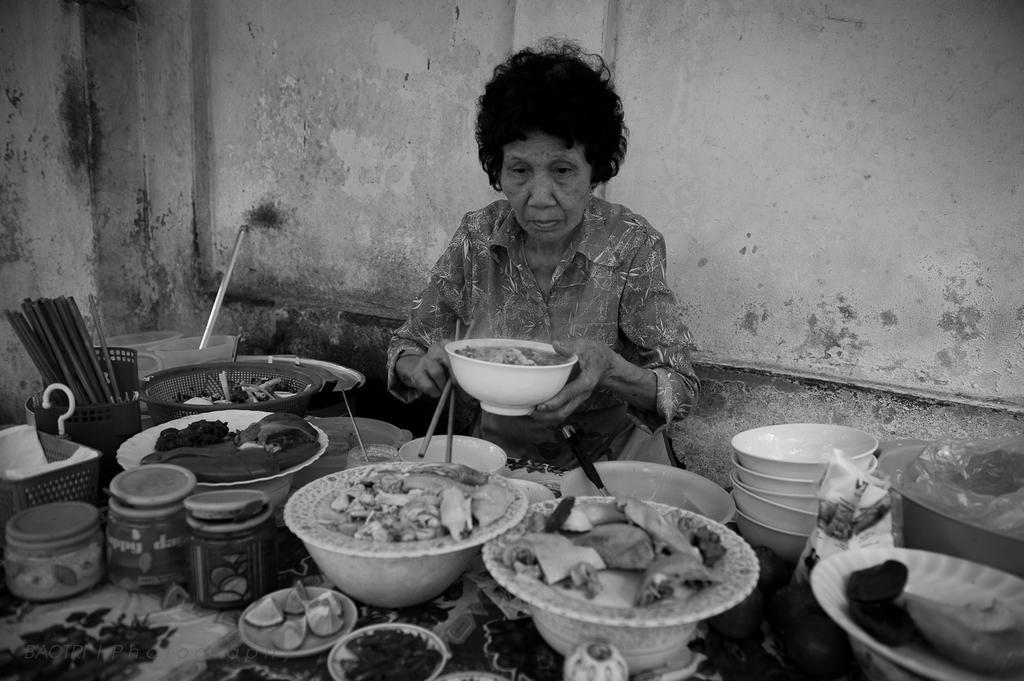Describe this image in one or two sentences. In this image there is a woman holding the bowl. In front of her there is a table. On top of it there are food items on a plates. There are bowls. There are chopsticks. There are slices of lemon on a plate and a few other objects. In the background of the image there is a wall. 